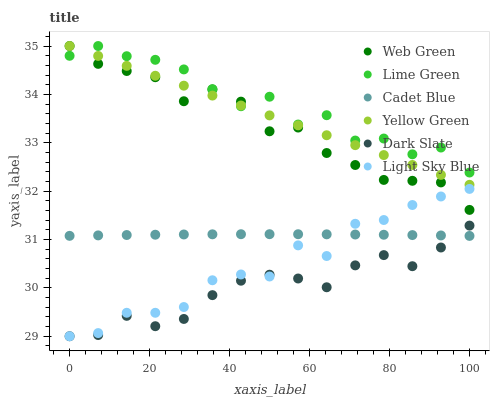Does Dark Slate have the minimum area under the curve?
Answer yes or no. Yes. Does Lime Green have the maximum area under the curve?
Answer yes or no. Yes. Does Yellow Green have the minimum area under the curve?
Answer yes or no. No. Does Yellow Green have the maximum area under the curve?
Answer yes or no. No. Is Yellow Green the smoothest?
Answer yes or no. Yes. Is Lime Green the roughest?
Answer yes or no. Yes. Is Web Green the smoothest?
Answer yes or no. No. Is Web Green the roughest?
Answer yes or no. No. Does Dark Slate have the lowest value?
Answer yes or no. Yes. Does Yellow Green have the lowest value?
Answer yes or no. No. Does Lime Green have the highest value?
Answer yes or no. Yes. Does Dark Slate have the highest value?
Answer yes or no. No. Is Cadet Blue less than Yellow Green?
Answer yes or no. Yes. Is Web Green greater than Cadet Blue?
Answer yes or no. Yes. Does Lime Green intersect Web Green?
Answer yes or no. Yes. Is Lime Green less than Web Green?
Answer yes or no. No. Is Lime Green greater than Web Green?
Answer yes or no. No. Does Cadet Blue intersect Yellow Green?
Answer yes or no. No. 